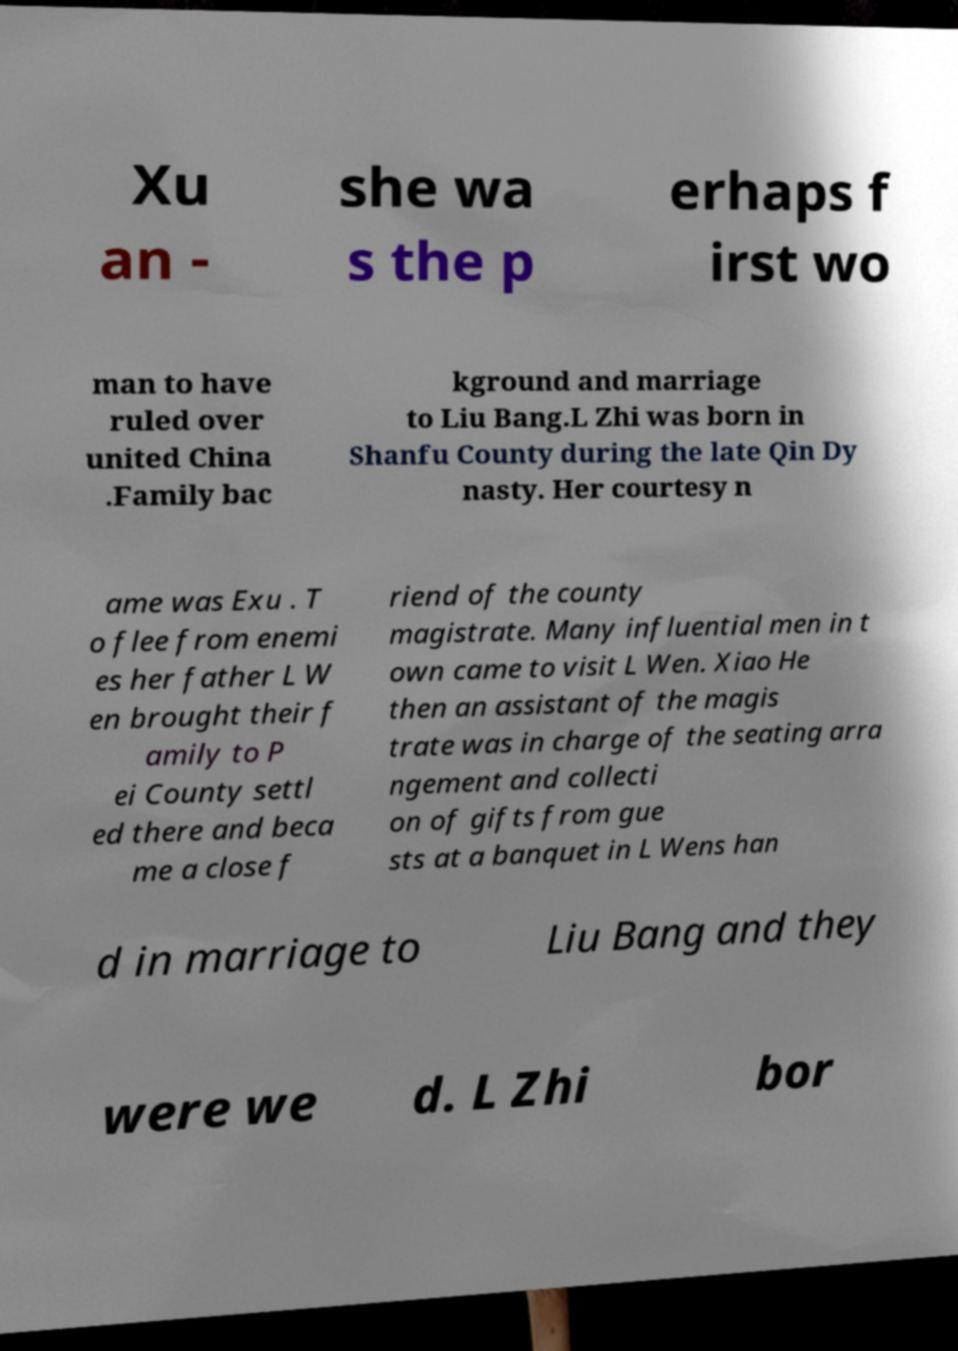For documentation purposes, I need the text within this image transcribed. Could you provide that? Xu an - she wa s the p erhaps f irst wo man to have ruled over united China .Family bac kground and marriage to Liu Bang.L Zhi was born in Shanfu County during the late Qin Dy nasty. Her courtesy n ame was Exu . T o flee from enemi es her father L W en brought their f amily to P ei County settl ed there and beca me a close f riend of the county magistrate. Many influential men in t own came to visit L Wen. Xiao He then an assistant of the magis trate was in charge of the seating arra ngement and collecti on of gifts from gue sts at a banquet in L Wens han d in marriage to Liu Bang and they were we d. L Zhi bor 